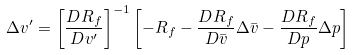<formula> <loc_0><loc_0><loc_500><loc_500>\Delta v ^ { \prime } = \left [ \frac { D R _ { f } } { D v ^ { \prime } } \right ] ^ { - 1 } \left [ - R _ { f } - \frac { D R _ { f } } { D \bar { v } } \Delta \bar { v } - \frac { D R _ { f } } { D p } \Delta p \right ]</formula> 